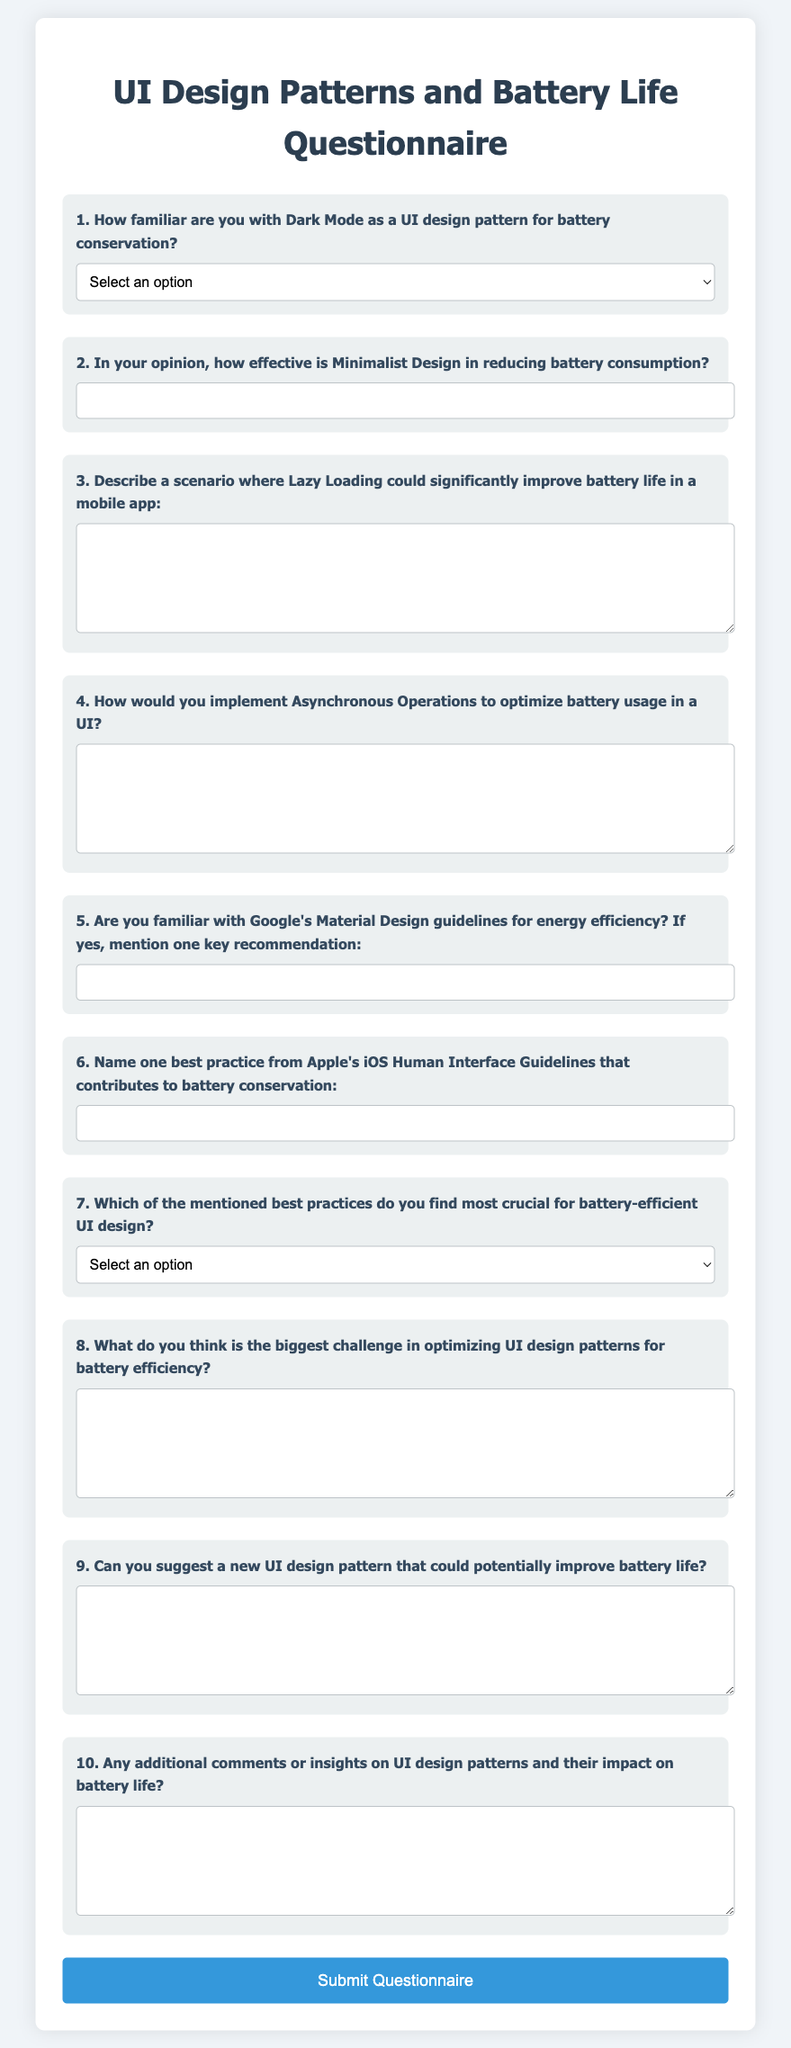What is the title of the document? The title of the document is explicitly stated in the <title> tag of the HTML code.
Answer: UI Design Patterns and Battery Life Questionnaire What is the first question in the questionnaire? The first question is provided in the form with a label element describing it.
Answer: How familiar are you with Dark Mode as a UI design pattern for battery conservation? How many questions are included in the questionnaire? The total number of questions can be counted from the form structure in the document.
Answer: 10 What is the background color of the body in the document? The body background color is defined in the CSS styles section of the HTML code.
Answer: #f0f4f8 Which option is included in the best practices dropdown menu? The dropdown options are listed in the HTML code under the best practices question.
Answer: Using dark mode What type of input is used for the question about Lazy Loading? The question type can be identified by analyzing the input tag used for the question.
Answer: Textarea Name one key recommendation from Google's Material Design guidelines mentioned in the questionnaire. The question prompts for a specific input regarding a recommendation from the guidelines.
Answer: (user would provide an answer) What question number is related to challenges in battery efficiency? The question number can be determined from the sequence of questions in the questionnaire.
Answer: 8 What is the purpose of the submit button in the form? The function of the submit button is described in the button element within the form.
Answer: Submit Questionnaire 